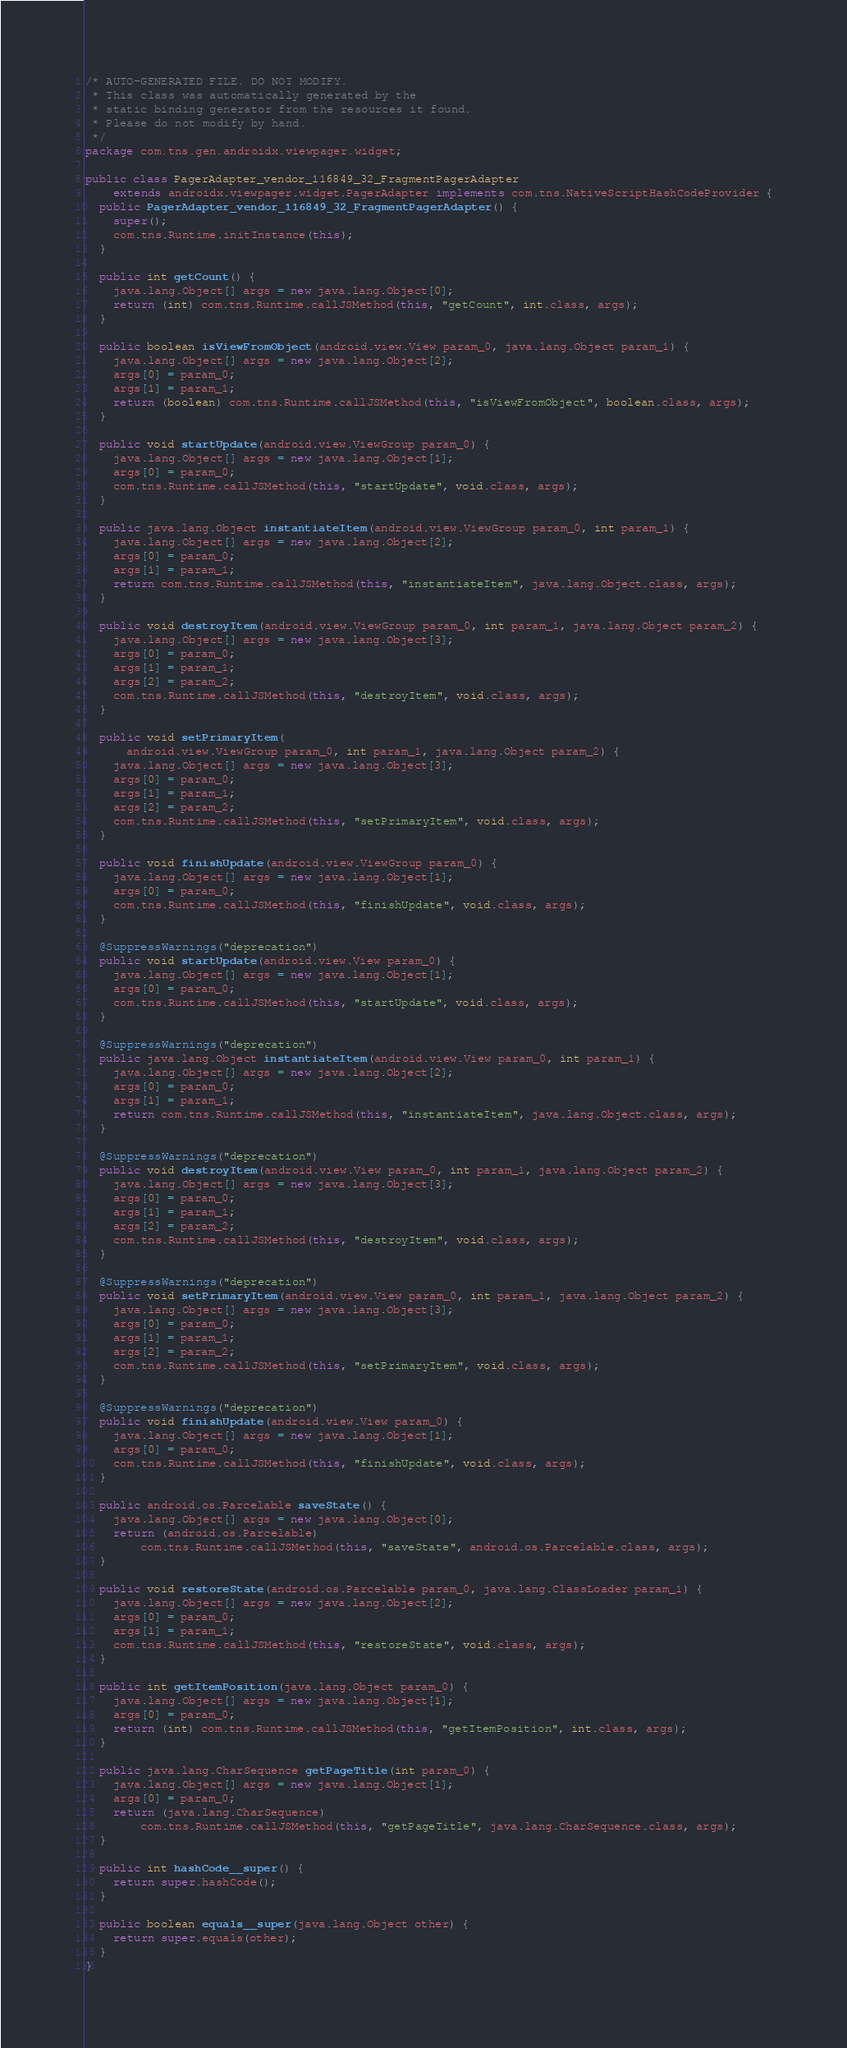Convert code to text. <code><loc_0><loc_0><loc_500><loc_500><_Java_>/* AUTO-GENERATED FILE. DO NOT MODIFY.
 * This class was automatically generated by the
 * static binding generator from the resources it found.
 * Please do not modify by hand.
 */
package com.tns.gen.androidx.viewpager.widget;

public class PagerAdapter_vendor_116849_32_FragmentPagerAdapter
    extends androidx.viewpager.widget.PagerAdapter implements com.tns.NativeScriptHashCodeProvider {
  public PagerAdapter_vendor_116849_32_FragmentPagerAdapter() {
    super();
    com.tns.Runtime.initInstance(this);
  }

  public int getCount() {
    java.lang.Object[] args = new java.lang.Object[0];
    return (int) com.tns.Runtime.callJSMethod(this, "getCount", int.class, args);
  }

  public boolean isViewFromObject(android.view.View param_0, java.lang.Object param_1) {
    java.lang.Object[] args = new java.lang.Object[2];
    args[0] = param_0;
    args[1] = param_1;
    return (boolean) com.tns.Runtime.callJSMethod(this, "isViewFromObject", boolean.class, args);
  }

  public void startUpdate(android.view.ViewGroup param_0) {
    java.lang.Object[] args = new java.lang.Object[1];
    args[0] = param_0;
    com.tns.Runtime.callJSMethod(this, "startUpdate", void.class, args);
  }

  public java.lang.Object instantiateItem(android.view.ViewGroup param_0, int param_1) {
    java.lang.Object[] args = new java.lang.Object[2];
    args[0] = param_0;
    args[1] = param_1;
    return com.tns.Runtime.callJSMethod(this, "instantiateItem", java.lang.Object.class, args);
  }

  public void destroyItem(android.view.ViewGroup param_0, int param_1, java.lang.Object param_2) {
    java.lang.Object[] args = new java.lang.Object[3];
    args[0] = param_0;
    args[1] = param_1;
    args[2] = param_2;
    com.tns.Runtime.callJSMethod(this, "destroyItem", void.class, args);
  }

  public void setPrimaryItem(
      android.view.ViewGroup param_0, int param_1, java.lang.Object param_2) {
    java.lang.Object[] args = new java.lang.Object[3];
    args[0] = param_0;
    args[1] = param_1;
    args[2] = param_2;
    com.tns.Runtime.callJSMethod(this, "setPrimaryItem", void.class, args);
  }

  public void finishUpdate(android.view.ViewGroup param_0) {
    java.lang.Object[] args = new java.lang.Object[1];
    args[0] = param_0;
    com.tns.Runtime.callJSMethod(this, "finishUpdate", void.class, args);
  }

  @SuppressWarnings("deprecation")
  public void startUpdate(android.view.View param_0) {
    java.lang.Object[] args = new java.lang.Object[1];
    args[0] = param_0;
    com.tns.Runtime.callJSMethod(this, "startUpdate", void.class, args);
  }

  @SuppressWarnings("deprecation")
  public java.lang.Object instantiateItem(android.view.View param_0, int param_1) {
    java.lang.Object[] args = new java.lang.Object[2];
    args[0] = param_0;
    args[1] = param_1;
    return com.tns.Runtime.callJSMethod(this, "instantiateItem", java.lang.Object.class, args);
  }

  @SuppressWarnings("deprecation")
  public void destroyItem(android.view.View param_0, int param_1, java.lang.Object param_2) {
    java.lang.Object[] args = new java.lang.Object[3];
    args[0] = param_0;
    args[1] = param_1;
    args[2] = param_2;
    com.tns.Runtime.callJSMethod(this, "destroyItem", void.class, args);
  }

  @SuppressWarnings("deprecation")
  public void setPrimaryItem(android.view.View param_0, int param_1, java.lang.Object param_2) {
    java.lang.Object[] args = new java.lang.Object[3];
    args[0] = param_0;
    args[1] = param_1;
    args[2] = param_2;
    com.tns.Runtime.callJSMethod(this, "setPrimaryItem", void.class, args);
  }

  @SuppressWarnings("deprecation")
  public void finishUpdate(android.view.View param_0) {
    java.lang.Object[] args = new java.lang.Object[1];
    args[0] = param_0;
    com.tns.Runtime.callJSMethod(this, "finishUpdate", void.class, args);
  }

  public android.os.Parcelable saveState() {
    java.lang.Object[] args = new java.lang.Object[0];
    return (android.os.Parcelable)
        com.tns.Runtime.callJSMethod(this, "saveState", android.os.Parcelable.class, args);
  }

  public void restoreState(android.os.Parcelable param_0, java.lang.ClassLoader param_1) {
    java.lang.Object[] args = new java.lang.Object[2];
    args[0] = param_0;
    args[1] = param_1;
    com.tns.Runtime.callJSMethod(this, "restoreState", void.class, args);
  }

  public int getItemPosition(java.lang.Object param_0) {
    java.lang.Object[] args = new java.lang.Object[1];
    args[0] = param_0;
    return (int) com.tns.Runtime.callJSMethod(this, "getItemPosition", int.class, args);
  }

  public java.lang.CharSequence getPageTitle(int param_0) {
    java.lang.Object[] args = new java.lang.Object[1];
    args[0] = param_0;
    return (java.lang.CharSequence)
        com.tns.Runtime.callJSMethod(this, "getPageTitle", java.lang.CharSequence.class, args);
  }

  public int hashCode__super() {
    return super.hashCode();
  }

  public boolean equals__super(java.lang.Object other) {
    return super.equals(other);
  }
}
</code> 